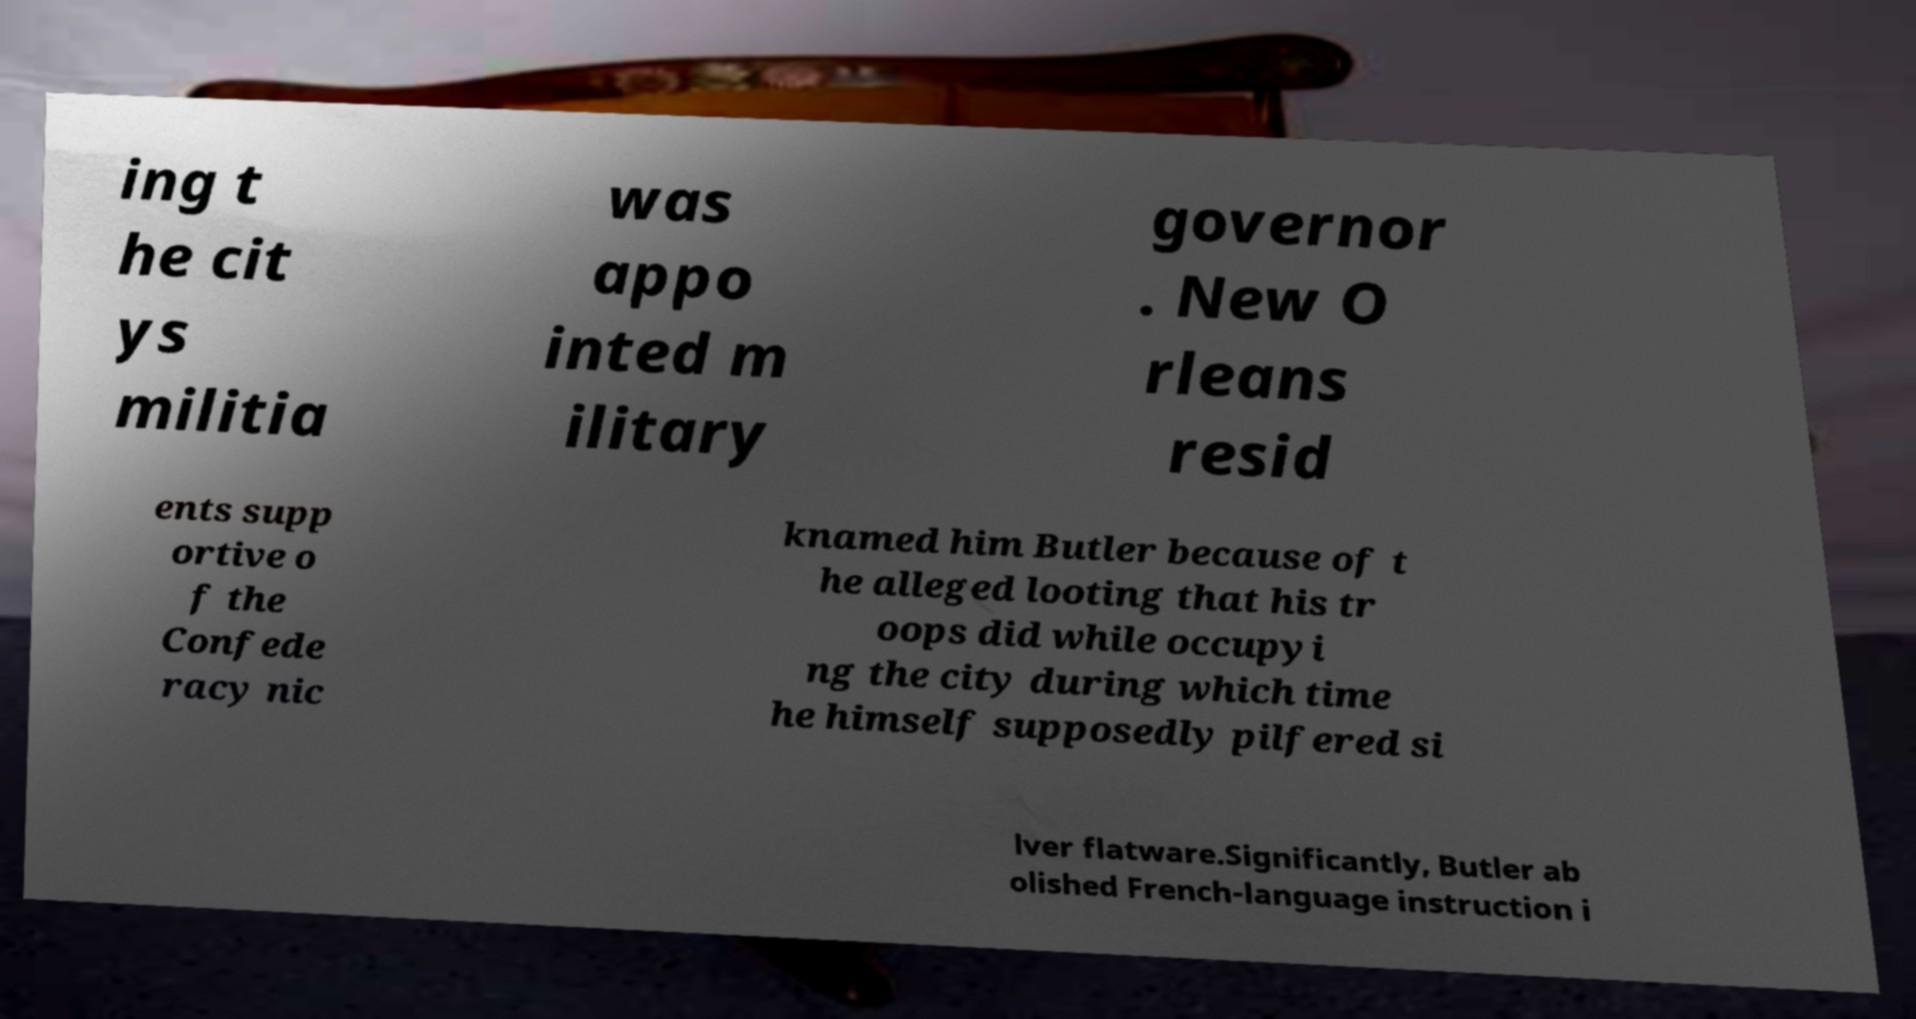Please identify and transcribe the text found in this image. ing t he cit ys militia was appo inted m ilitary governor . New O rleans resid ents supp ortive o f the Confede racy nic knamed him Butler because of t he alleged looting that his tr oops did while occupyi ng the city during which time he himself supposedly pilfered si lver flatware.Significantly, Butler ab olished French-language instruction i 